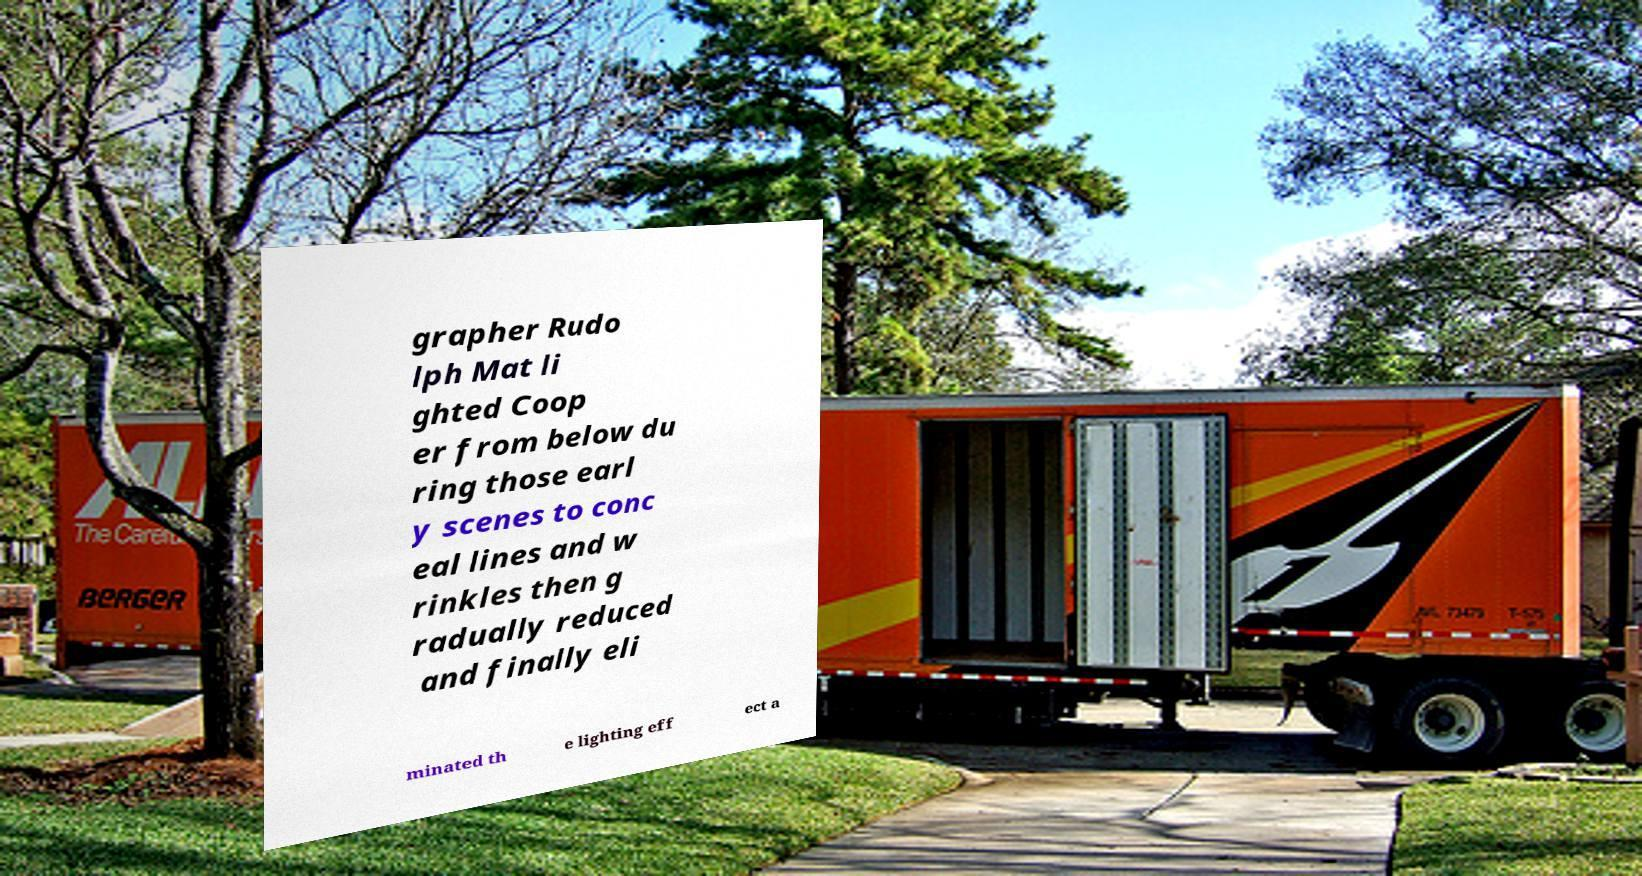Please read and relay the text visible in this image. What does it say? grapher Rudo lph Mat li ghted Coop er from below du ring those earl y scenes to conc eal lines and w rinkles then g radually reduced and finally eli minated th e lighting eff ect a 